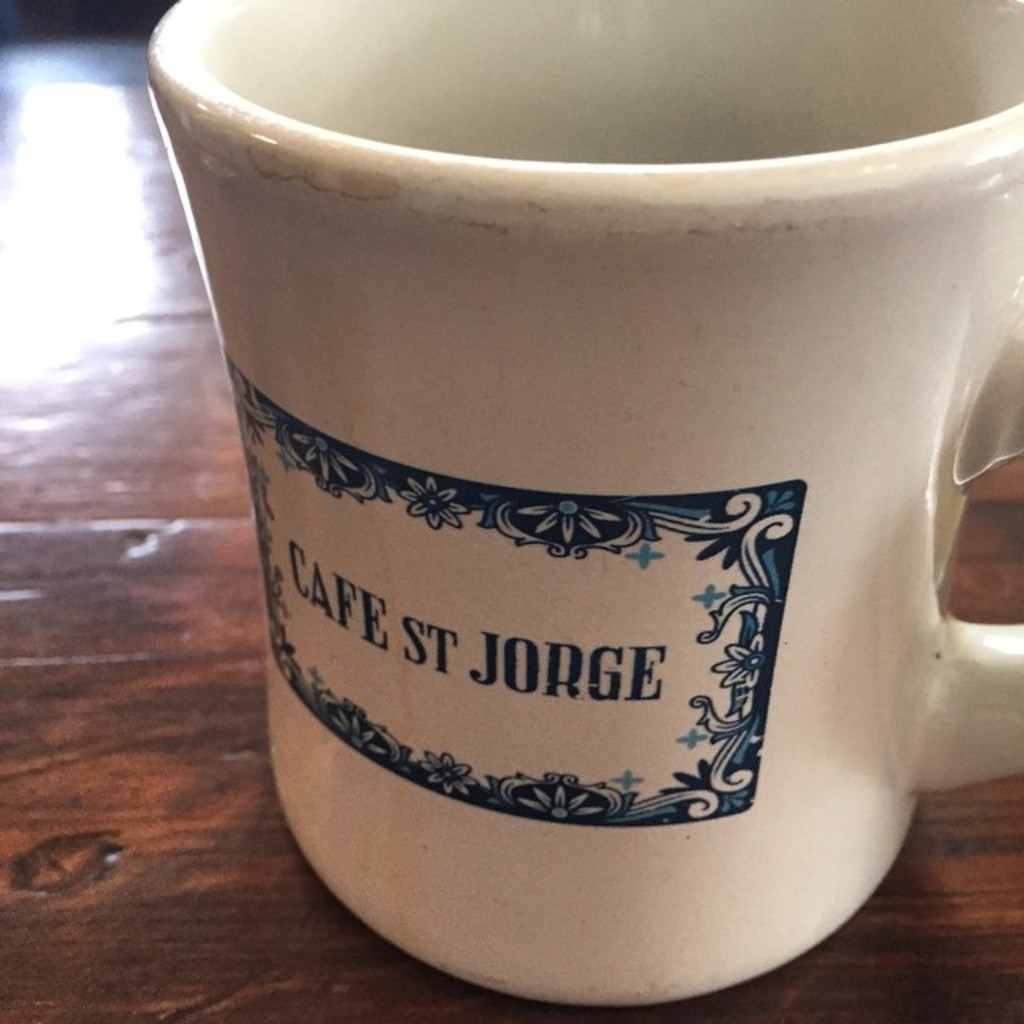Provide a one-sentence caption for the provided image.
Reference OCR token: CAPE, ST, JORGE The mug on the table is from Cafe ST Jorge. 